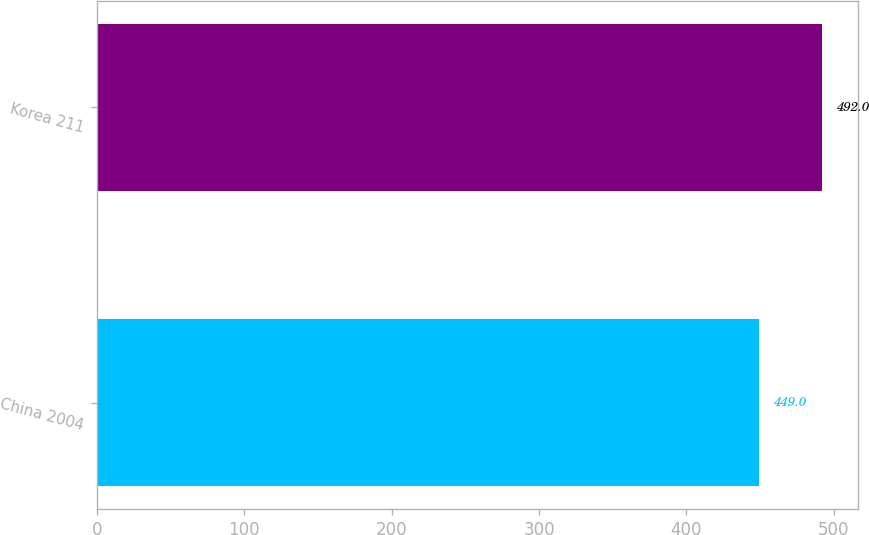Convert chart to OTSL. <chart><loc_0><loc_0><loc_500><loc_500><bar_chart><fcel>China 2004<fcel>Korea 211<nl><fcel>449<fcel>492<nl></chart> 